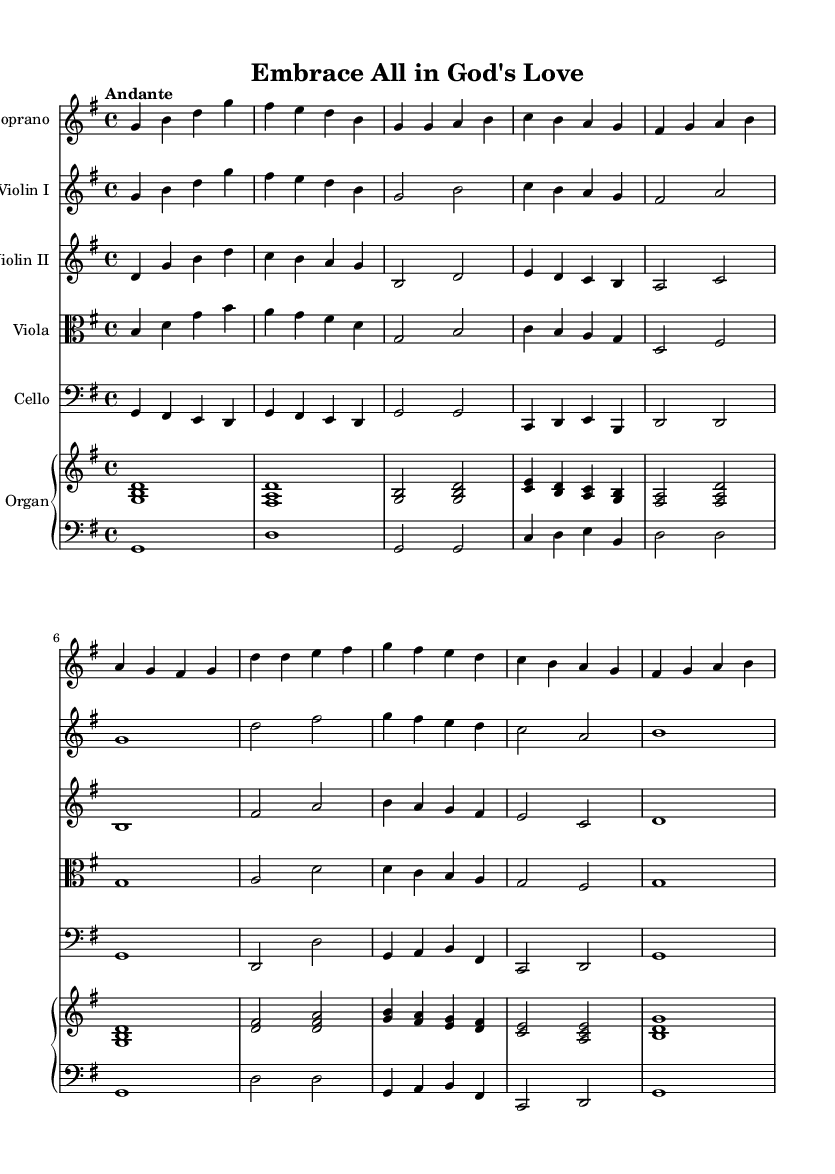What is the key signature of this music? The key signature shown in the music has one sharp, which corresponds to the key of G major.
Answer: G major What is the time signature? The time signature is identified as 4/4, which means there are four beats in each measure.
Answer: 4/4 What is the tempo marking? The tempo marking in the music indicates an “Andante” speed, which suggests a moderate pace.
Answer: Andante How many instruments are featured in the score? By examining the score, there are six distinct instrument parts presented, including vocals and strings.
Answer: Six What is the range of the soprano part? In the soprano part, the notes start from G and go up to B, showing its melodic range.
Answer: G to B Why does the music use different string instruments? The combination of violin I, violin II, viola, and cello enriches the harmonic texture typical of Baroque music, promoting a fuller sound.
Answer: To enrich harmonic texture What is the primary theme expressed in the title? The title “Embrace All in God's Love” suggests a focus on inclusivity, reflecting diverse spiritual acceptance in the context of sacred music.
Answer: Inclusivity 